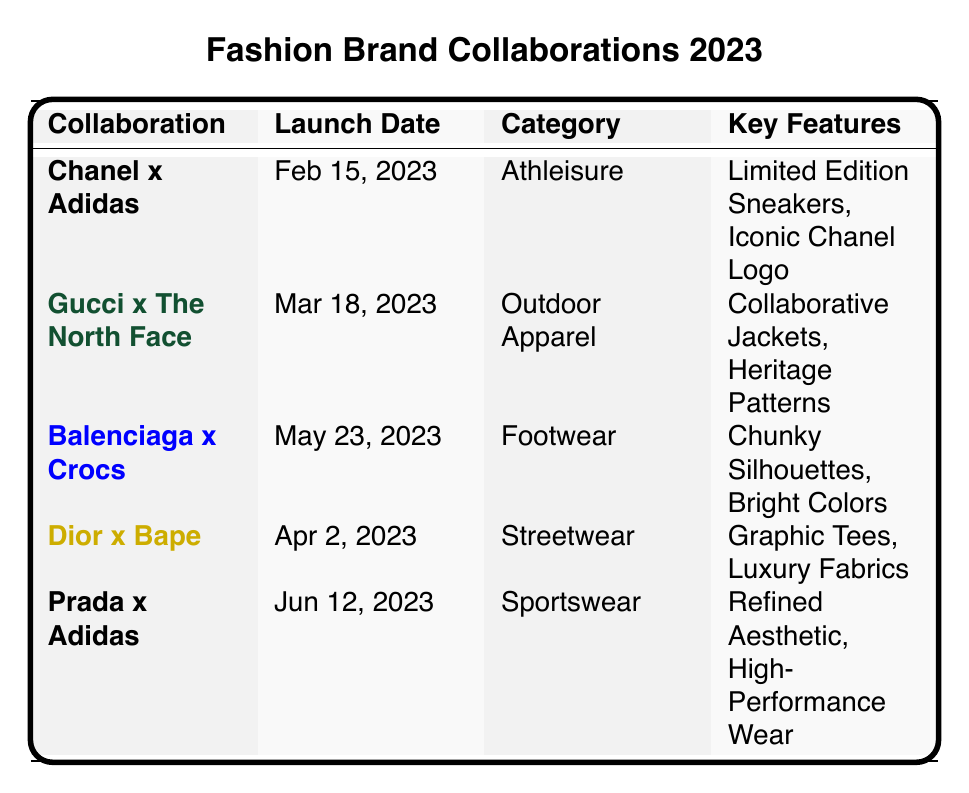What are the key features of the Chanel x Adidas collaboration? The key features listed for the Chanel x Adidas collaboration are "Limited Edition Sneakers" and "Iconic Chanel Logo".
Answer: Limited Edition Sneakers, Iconic Chanel Logo When was the Gucci x The North Face collaboration launched? The launch date for the Gucci x The North Face collaboration is noted as March 18, 2023.
Answer: March 18, 2023 Which collaboration falls under the category of Footwear? The table shows that the collaboration between Balenciaga and Crocs is categorized as Footwear.
Answer: Balenciaga x Crocs How many collaborations have been launched so far as of September 2023? The table contains seven collaborations, detailing each launch, including the one on September 5, 2023.
Answer: Seven What are the target audiences for the Prada x Adidas collaboration? The target audiences mentioned for the Prada x Adidas collaboration include "Active Lifestyles", "Luxury Athletes", and "Modern Professionals".
Answer: Active Lifestyles, Luxury Athletes, Modern Professionals Is the Dior x Bape collaboration categorized as Outdoor Apparel? The Dior x Bape collaboration is categorized as Streetwear, not Outdoor Apparel, which is specified for the Gucci x The North Face collaboration.
Answer: False Which collaboration features luxury comfort as a key feature? The Fendi x Skims collaboration emphasizes "Luxury Comfort" as one of its key features.
Answer: Fendi x Skims What is the youngest launch date among the collaborations listed? The youngest launch date is October 10, 2023, for the Fendi x Skims collaboration, which is later than all others provided in the table.
Answer: October 10, 2023 How many brands collaborated with Adidas in 2023? Two collaborations include Adidas: Chanel x Adidas and Prada x Adidas, documented in the data.
Answer: Two Which collaboration targets youthful shoppers? The Versace x H&M collaboration is specifically targeting youthful shoppers, as noted in the table's target audience list.
Answer: Versace x H&M Are there any collaborations that include sustainable practices as a key feature? Yes, the Gucci x The North Face collaboration mentions "Eco-Friendly Practices" as one of its key features, indicating sustainable practices.
Answer: Yes 